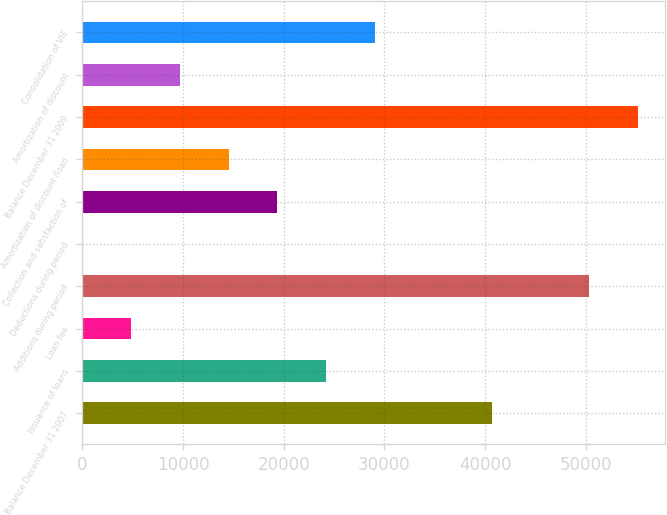Convert chart to OTSL. <chart><loc_0><loc_0><loc_500><loc_500><bar_chart><fcel>Balance December 31 2007<fcel>Issuance of loans<fcel>Loan fee<fcel>Additions during period<fcel>Deductions during period<fcel>Collection and satisfaction of<fcel>Amortization of discount /loan<fcel>Balance December 31 2009<fcel>Amortization of discount<fcel>Consolidation of VIE<nl><fcel>40638<fcel>24175.5<fcel>4847.1<fcel>50302.2<fcel>15<fcel>19343.4<fcel>14511.3<fcel>55134.3<fcel>9679.2<fcel>29007.6<nl></chart> 